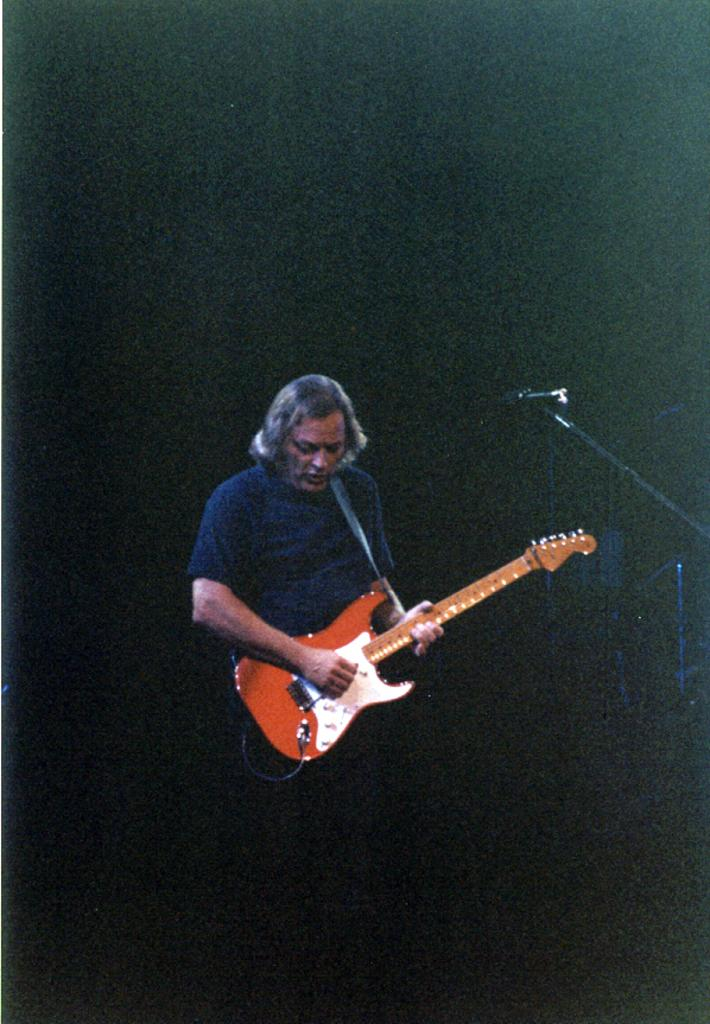What is the general color scheme of the background in the image? The background of the image is dark. Can you describe the person in the image? There is a man with short hair in the image. What is the man doing in the image? The man is standing in front of a microphone and playing a guitar. How many babies are visible in the image? There are no babies present in the image. What historical event is taking place in the image? There is no historical event depicted in the image; it features a man playing a guitar in front of a microphone. 